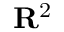Convert formula to latex. <formula><loc_0><loc_0><loc_500><loc_500>R ^ { 2 }</formula> 